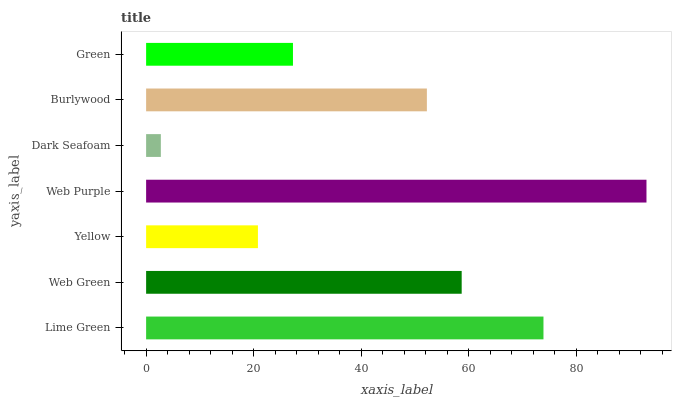Is Dark Seafoam the minimum?
Answer yes or no. Yes. Is Web Purple the maximum?
Answer yes or no. Yes. Is Web Green the minimum?
Answer yes or no. No. Is Web Green the maximum?
Answer yes or no. No. Is Lime Green greater than Web Green?
Answer yes or no. Yes. Is Web Green less than Lime Green?
Answer yes or no. Yes. Is Web Green greater than Lime Green?
Answer yes or no. No. Is Lime Green less than Web Green?
Answer yes or no. No. Is Burlywood the high median?
Answer yes or no. Yes. Is Burlywood the low median?
Answer yes or no. Yes. Is Dark Seafoam the high median?
Answer yes or no. No. Is Dark Seafoam the low median?
Answer yes or no. No. 